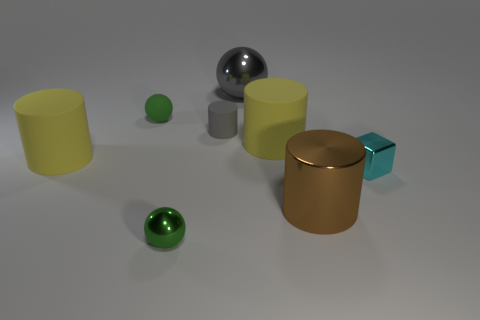Does the size of the objects give a clue about their potential use or function? The objects in the image vary in size, which could imply different uses or functions. The larger cylindrical objects could serve as containers or decorative pieces, given their size and shape. The smaller balls might serve as decorative elements as well, or their size makes it conceivable they could be part of a larger mechanism or game. Without additional context, it's challenging to determine their specific purpose, but their simple geometries suggest they could be versatile in their applications. 